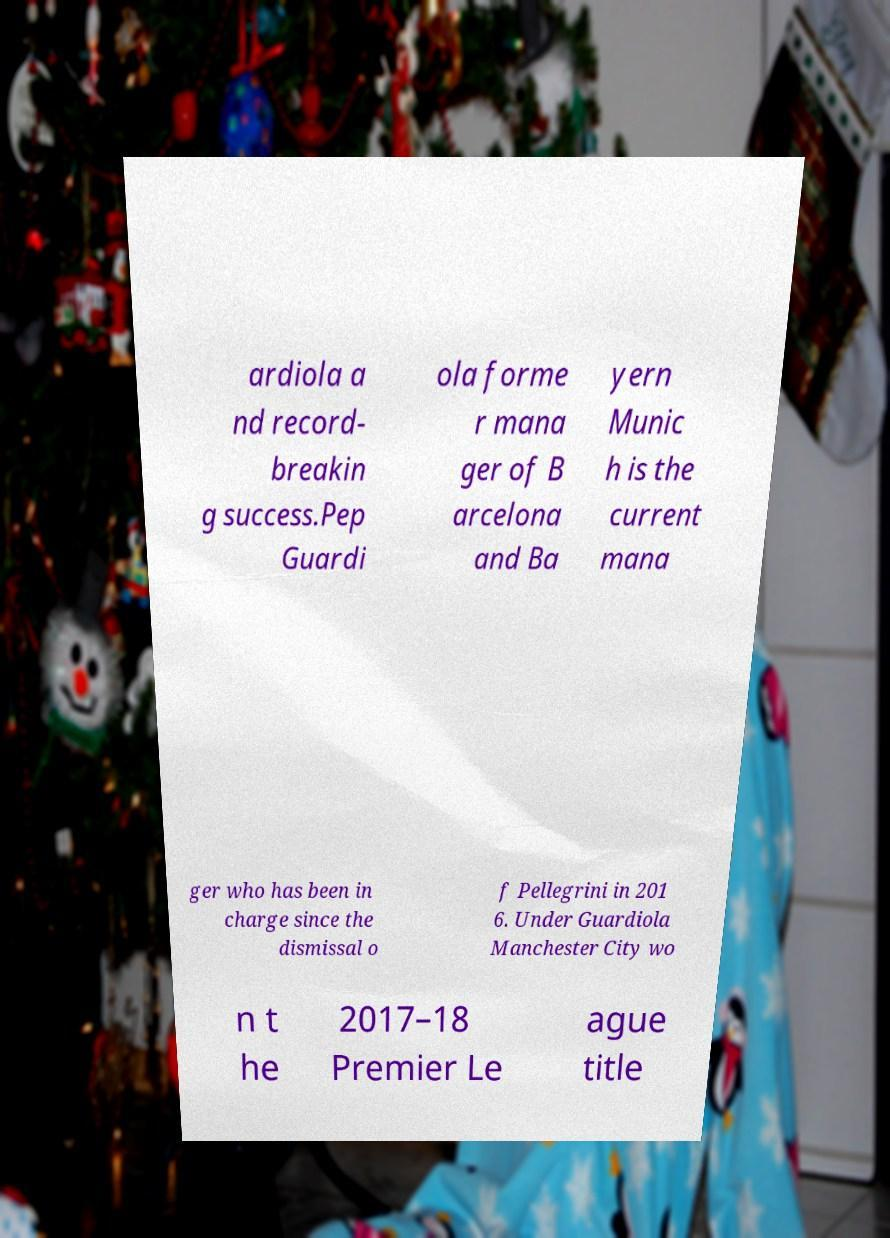Please read and relay the text visible in this image. What does it say? ardiola a nd record- breakin g success.Pep Guardi ola forme r mana ger of B arcelona and Ba yern Munic h is the current mana ger who has been in charge since the dismissal o f Pellegrini in 201 6. Under Guardiola Manchester City wo n t he 2017–18 Premier Le ague title 